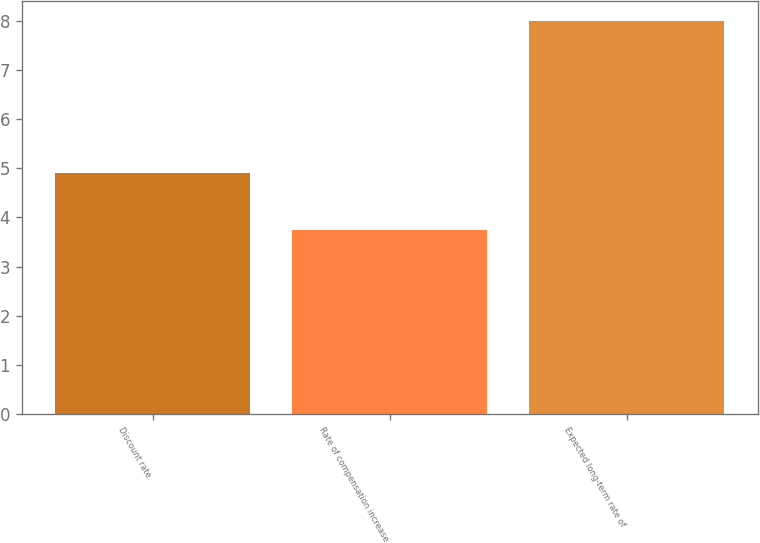<chart> <loc_0><loc_0><loc_500><loc_500><bar_chart><fcel>Discount rate<fcel>Rate of compensation increase<fcel>Expected long-term rate of<nl><fcel>4.9<fcel>3.75<fcel>8<nl></chart> 